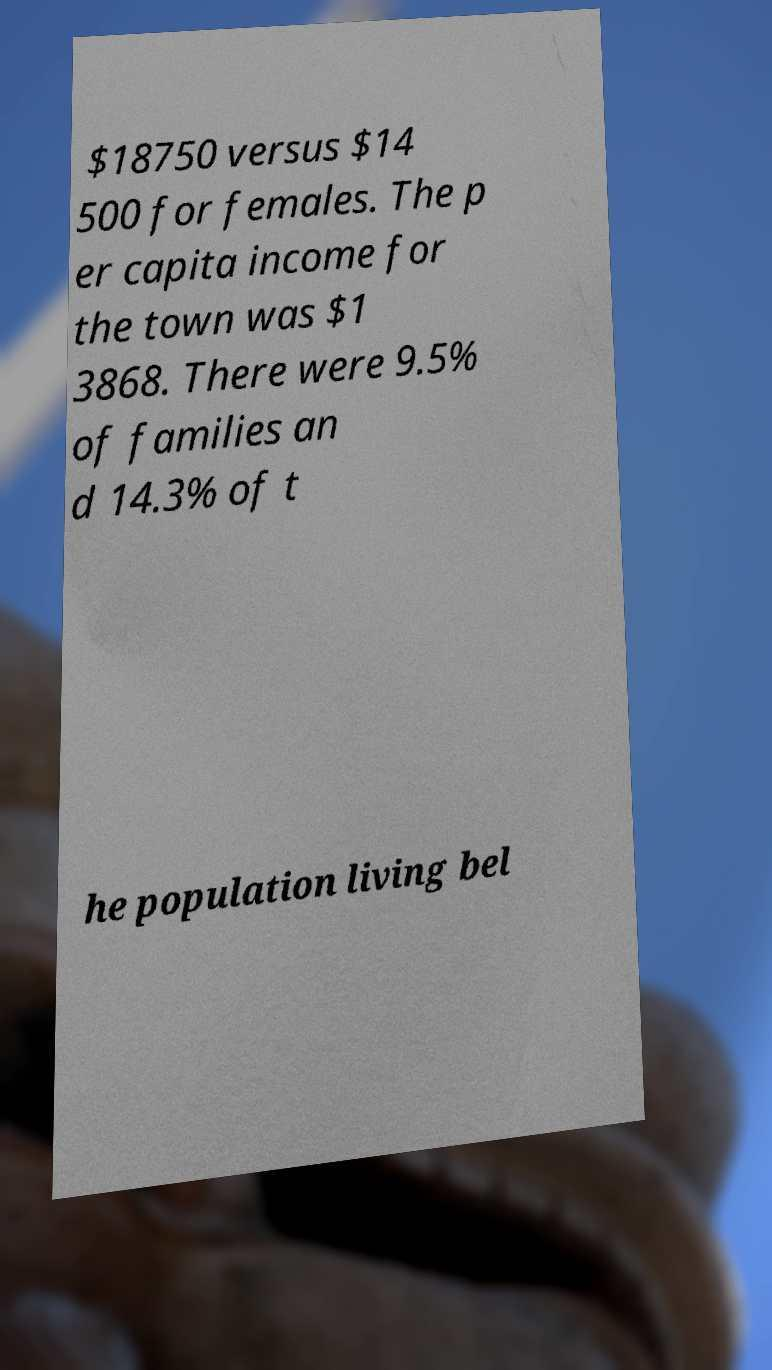I need the written content from this picture converted into text. Can you do that? $18750 versus $14 500 for females. The p er capita income for the town was $1 3868. There were 9.5% of families an d 14.3% of t he population living bel 